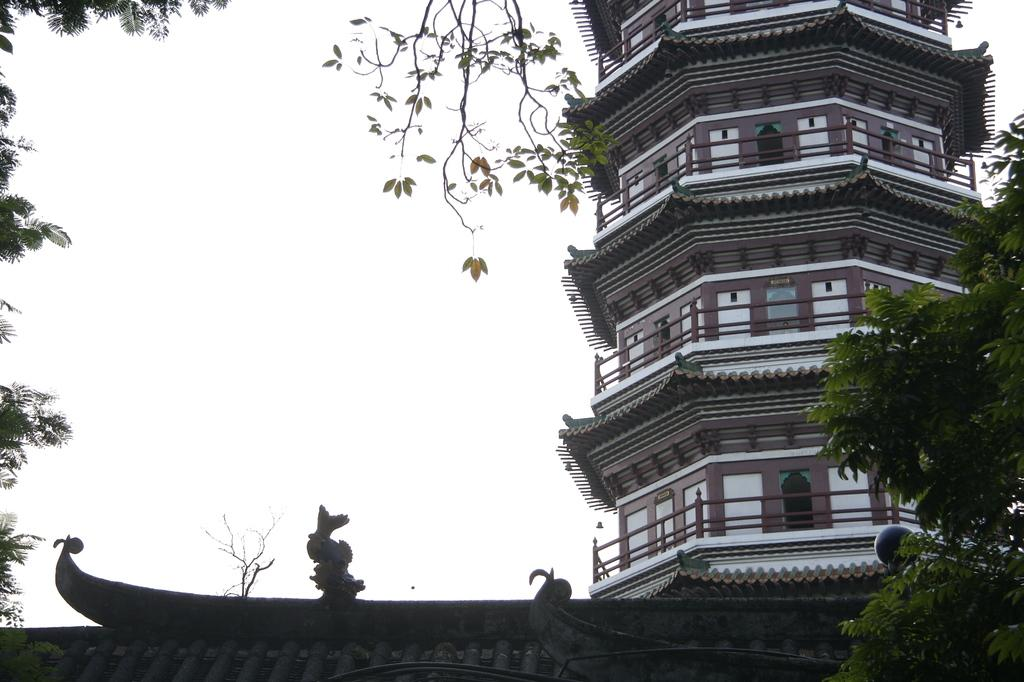What is the main structure in the picture? There is a Pagoda in the picture. Where are the trees located in the picture? The trees are in the right corner of the picture. How many cattle can be seen grazing on the ground in the picture? There are no cattle present in the picture; it only features a Pagoda and trees. 